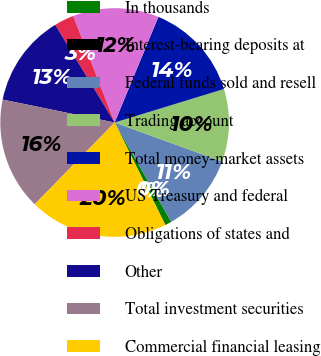Convert chart. <chart><loc_0><loc_0><loc_500><loc_500><pie_chart><fcel>In thousands<fcel>Interest-bearing deposits at<fcel>Federal funds sold and resell<fcel>Trading account<fcel>Total money-market assets<fcel>US Treasury and federal<fcel>Obligations of states and<fcel>Other<fcel>Total investment securities<fcel>Commercial financial leasing<nl><fcel>0.93%<fcel>0.0%<fcel>11.21%<fcel>10.28%<fcel>14.02%<fcel>12.15%<fcel>2.8%<fcel>13.08%<fcel>15.89%<fcel>19.63%<nl></chart> 